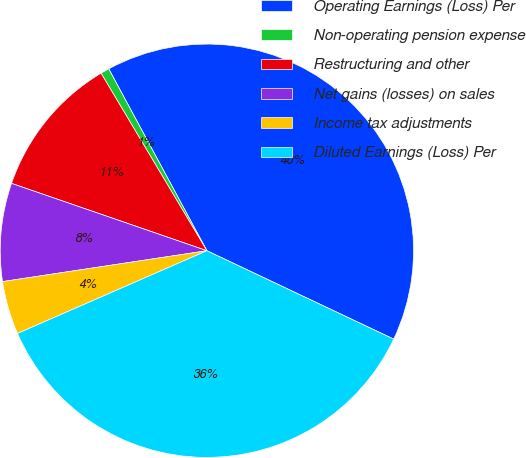Convert chart. <chart><loc_0><loc_0><loc_500><loc_500><pie_chart><fcel>Operating Earnings (Loss) Per<fcel>Non-operating pension expense<fcel>Restructuring and other<fcel>Net gains (losses) on sales<fcel>Income tax adjustments<fcel>Diluted Earnings (Loss) Per<nl><fcel>39.91%<fcel>0.68%<fcel>11.16%<fcel>7.67%<fcel>4.17%<fcel>36.41%<nl></chart> 